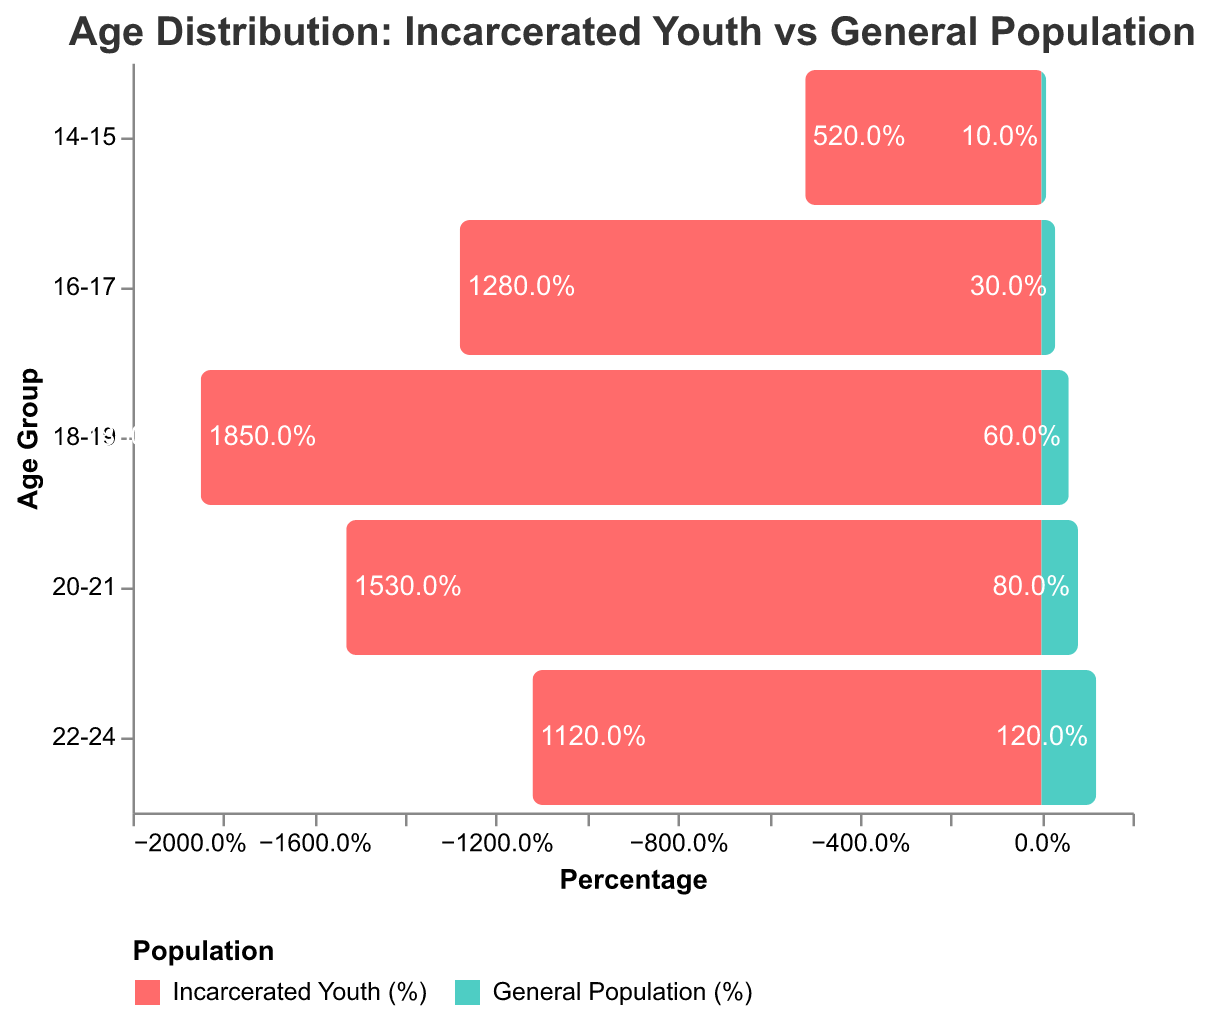What's the highest percentage of incarcerated youth falling into an age group? The chart shows the different age groups and their corresponding percentages. The highest bar for incarcerated youth is for the age group 18-19 with a percentage of 18.5%.
Answer: 18.5% What is the total percentage of incarcerated youth aged between 18 and 21? Sum the individual percentages for age groups 18-19 and 20-21: 18.5% + 15.3% = 33.8%.
Answer: 33.8% How does the percentage of general population age 16-17 compare to that of age 14-15? The bar for age group 16-17 in the general population is taller than that for age group 14-15. Specifically, it's 0.3% versus 0.1%.
Answer: 0.3% is greater than 0.1% Which group has a higher percentage of no high school diploma, incarcerated youth or the general population? The bars for no high school diploma show that incarcerated youth have a significantly higher percentage at 62.4% compared to the general population at 12.5%.
Answer: Incarcerated youth What's the difference in percentages for having a Bachelor's degree or higher between incarcerated youth and the general population? The chart shows 0.2% for incarcerated youth and 18.2% for the general population. The difference is 18.2% - 0.2% = 18%.
Answer: 18% What is the trend in incarcerated youth percentages from age 14-15 to age 22-24? The trend for incarcerated youth shows percentages increasing from age 14-15 to a peak at age 18-19 (5.2% to 18.5%), then gradually decreasing to age 22-24 (11.2%).
Answer: Peak at 18-19, then decrease Compare the percentage of some college education attainment between the general population and incarcerated youth. The bar for some college is much higher for the general population at 31.2% compared to incarcerated youth at 6.9%.
Answer: General population is higher How much higher is the percentage of high school diploma/GED attainment in the general population compared to the incarcerated youth? From the chart, general population has 28.3% and incarcerated youth have 29.8%. The difference is 29.8% - 28.3% = 1.5%.
Answer: 1.5% higher in incarcerated youth How does the educational attainment at the associate's degree level differ between incarcerated youth and the general population? The chart shows an associate's degree attainment of 0.7% for incarcerated youth and 9.8% for the general population, indicating a significant difference in favor of the general population.
Answer: General population is higher 